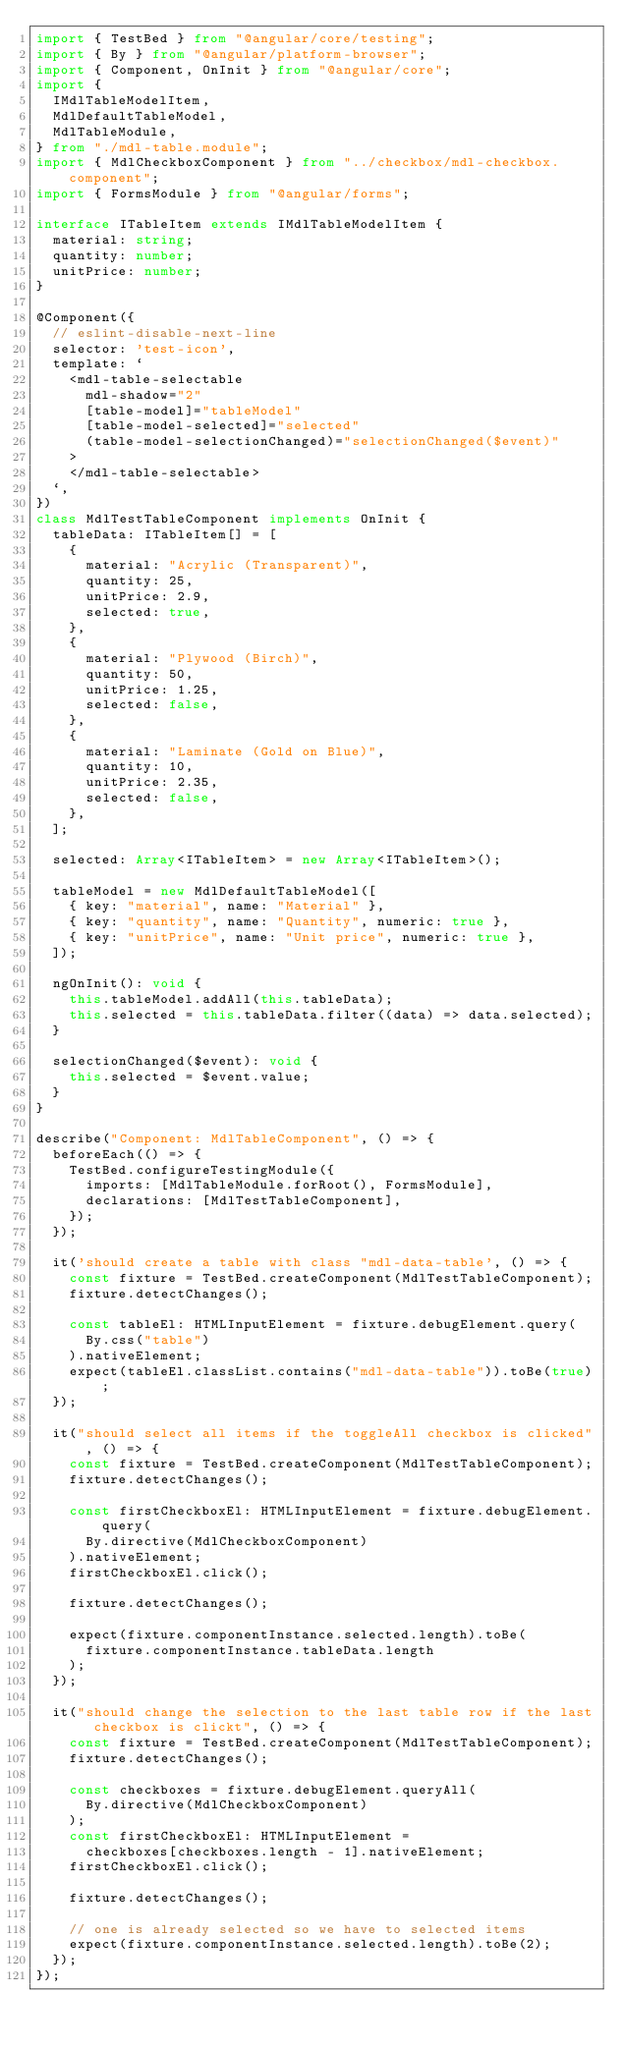<code> <loc_0><loc_0><loc_500><loc_500><_TypeScript_>import { TestBed } from "@angular/core/testing";
import { By } from "@angular/platform-browser";
import { Component, OnInit } from "@angular/core";
import {
  IMdlTableModelItem,
  MdlDefaultTableModel,
  MdlTableModule,
} from "./mdl-table.module";
import { MdlCheckboxComponent } from "../checkbox/mdl-checkbox.component";
import { FormsModule } from "@angular/forms";

interface ITableItem extends IMdlTableModelItem {
  material: string;
  quantity: number;
  unitPrice: number;
}

@Component({
  // eslint-disable-next-line
  selector: 'test-icon',
  template: `
    <mdl-table-selectable
      mdl-shadow="2"
      [table-model]="tableModel"
      [table-model-selected]="selected"
      (table-model-selectionChanged)="selectionChanged($event)"
    >
    </mdl-table-selectable>
  `,
})
class MdlTestTableComponent implements OnInit {
  tableData: ITableItem[] = [
    {
      material: "Acrylic (Transparent)",
      quantity: 25,
      unitPrice: 2.9,
      selected: true,
    },
    {
      material: "Plywood (Birch)",
      quantity: 50,
      unitPrice: 1.25,
      selected: false,
    },
    {
      material: "Laminate (Gold on Blue)",
      quantity: 10,
      unitPrice: 2.35,
      selected: false,
    },
  ];

  selected: Array<ITableItem> = new Array<ITableItem>();

  tableModel = new MdlDefaultTableModel([
    { key: "material", name: "Material" },
    { key: "quantity", name: "Quantity", numeric: true },
    { key: "unitPrice", name: "Unit price", numeric: true },
  ]);

  ngOnInit(): void {
    this.tableModel.addAll(this.tableData);
    this.selected = this.tableData.filter((data) => data.selected);
  }

  selectionChanged($event): void {
    this.selected = $event.value;
  }
}

describe("Component: MdlTableComponent", () => {
  beforeEach(() => {
    TestBed.configureTestingModule({
      imports: [MdlTableModule.forRoot(), FormsModule],
      declarations: [MdlTestTableComponent],
    });
  });

  it('should create a table with class "mdl-data-table', () => {
    const fixture = TestBed.createComponent(MdlTestTableComponent);
    fixture.detectChanges();

    const tableEl: HTMLInputElement = fixture.debugElement.query(
      By.css("table")
    ).nativeElement;
    expect(tableEl.classList.contains("mdl-data-table")).toBe(true);
  });

  it("should select all items if the toggleAll checkbox is clicked", () => {
    const fixture = TestBed.createComponent(MdlTestTableComponent);
    fixture.detectChanges();

    const firstCheckboxEl: HTMLInputElement = fixture.debugElement.query(
      By.directive(MdlCheckboxComponent)
    ).nativeElement;
    firstCheckboxEl.click();

    fixture.detectChanges();

    expect(fixture.componentInstance.selected.length).toBe(
      fixture.componentInstance.tableData.length
    );
  });

  it("should change the selection to the last table row if the last checkbox is clickt", () => {
    const fixture = TestBed.createComponent(MdlTestTableComponent);
    fixture.detectChanges();

    const checkboxes = fixture.debugElement.queryAll(
      By.directive(MdlCheckboxComponent)
    );
    const firstCheckboxEl: HTMLInputElement =
      checkboxes[checkboxes.length - 1].nativeElement;
    firstCheckboxEl.click();

    fixture.detectChanges();

    // one is already selected so we have to selected items
    expect(fixture.componentInstance.selected.length).toBe(2);
  });
});
</code> 